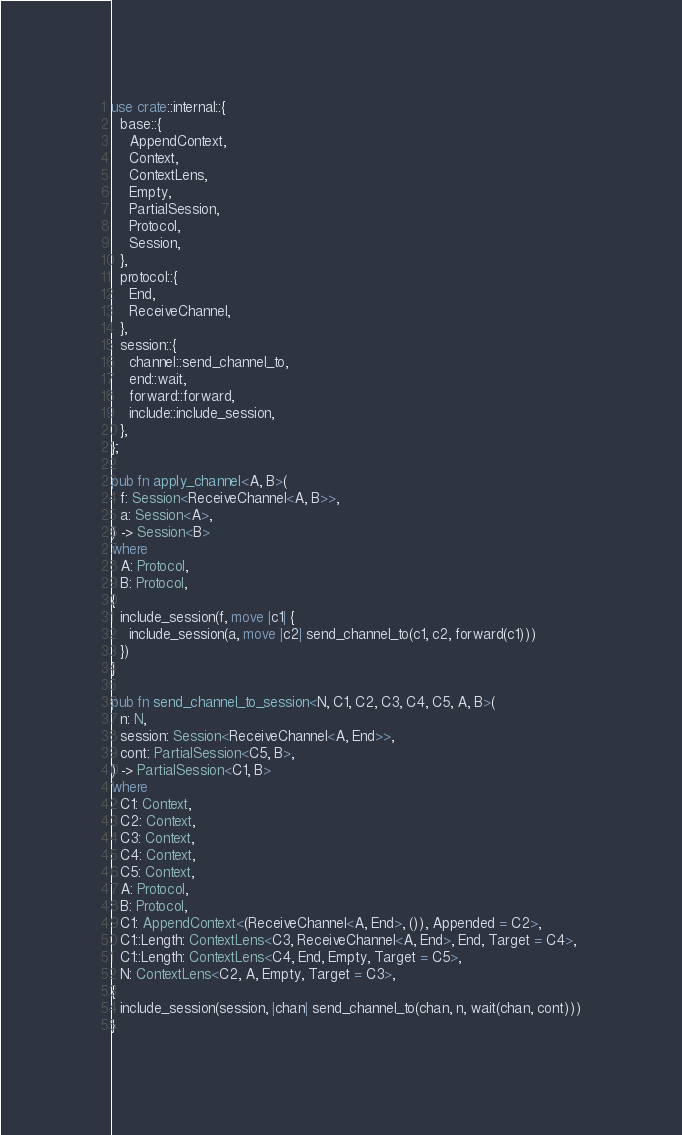Convert code to text. <code><loc_0><loc_0><loc_500><loc_500><_Rust_>use crate::internal::{
  base::{
    AppendContext,
    Context,
    ContextLens,
    Empty,
    PartialSession,
    Protocol,
    Session,
  },
  protocol::{
    End,
    ReceiveChannel,
  },
  session::{
    channel::send_channel_to,
    end::wait,
    forward::forward,
    include::include_session,
  },
};

pub fn apply_channel<A, B>(
  f: Session<ReceiveChannel<A, B>>,
  a: Session<A>,
) -> Session<B>
where
  A: Protocol,
  B: Protocol,
{
  include_session(f, move |c1| {
    include_session(a, move |c2| send_channel_to(c1, c2, forward(c1)))
  })
}

pub fn send_channel_to_session<N, C1, C2, C3, C4, C5, A, B>(
  n: N,
  session: Session<ReceiveChannel<A, End>>,
  cont: PartialSession<C5, B>,
) -> PartialSession<C1, B>
where
  C1: Context,
  C2: Context,
  C3: Context,
  C4: Context,
  C5: Context,
  A: Protocol,
  B: Protocol,
  C1: AppendContext<(ReceiveChannel<A, End>, ()), Appended = C2>,
  C1::Length: ContextLens<C3, ReceiveChannel<A, End>, End, Target = C4>,
  C1::Length: ContextLens<C4, End, Empty, Target = C5>,
  N: ContextLens<C2, A, Empty, Target = C3>,
{
  include_session(session, |chan| send_channel_to(chan, n, wait(chan, cont)))
}
</code> 